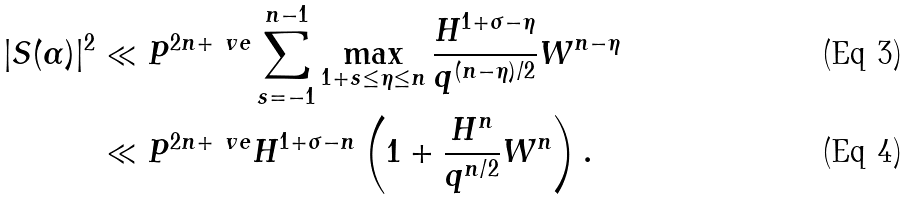Convert formula to latex. <formula><loc_0><loc_0><loc_500><loc_500>| S ( \alpha ) | ^ { 2 } & \ll P ^ { 2 n + \ v e } \sum _ { s = - 1 } ^ { n - 1 } \max _ { 1 + s \leq \eta \leq n } \frac { H ^ { 1 + \sigma - \eta } } { q ^ { ( n - \eta ) / 2 } } W ^ { n - \eta } \\ & \ll P ^ { 2 n + \ v e } H ^ { 1 + \sigma - n } \left ( 1 + \frac { H ^ { n } } { q ^ { n / 2 } } W ^ { n } \right ) .</formula> 